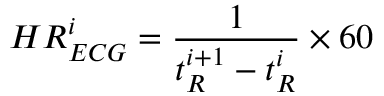Convert formula to latex. <formula><loc_0><loc_0><loc_500><loc_500>H R _ { E C G } ^ { i } = \frac { 1 } { t _ { R } ^ { i + 1 } - t _ { R } ^ { i } } \times 6 0</formula> 